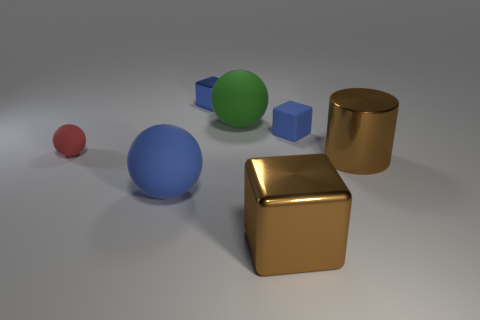Add 1 big red balls. How many objects exist? 8 Subtract all balls. How many objects are left? 4 Add 1 brown shiny cylinders. How many brown shiny cylinders are left? 2 Add 4 large green matte balls. How many large green matte balls exist? 5 Subtract 0 red cubes. How many objects are left? 7 Subtract all purple cylinders. Subtract all big brown metallic cubes. How many objects are left? 6 